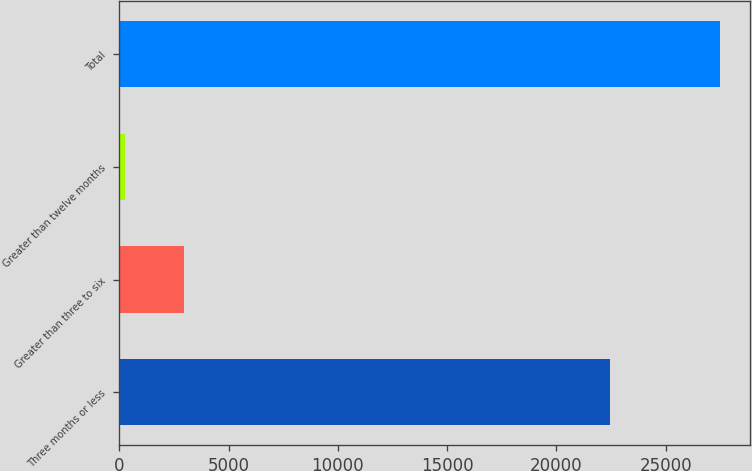<chart> <loc_0><loc_0><loc_500><loc_500><bar_chart><fcel>Three months or less<fcel>Greater than three to six<fcel>Greater than twelve months<fcel>Total<nl><fcel>22449<fcel>2962.5<fcel>240<fcel>27465<nl></chart> 